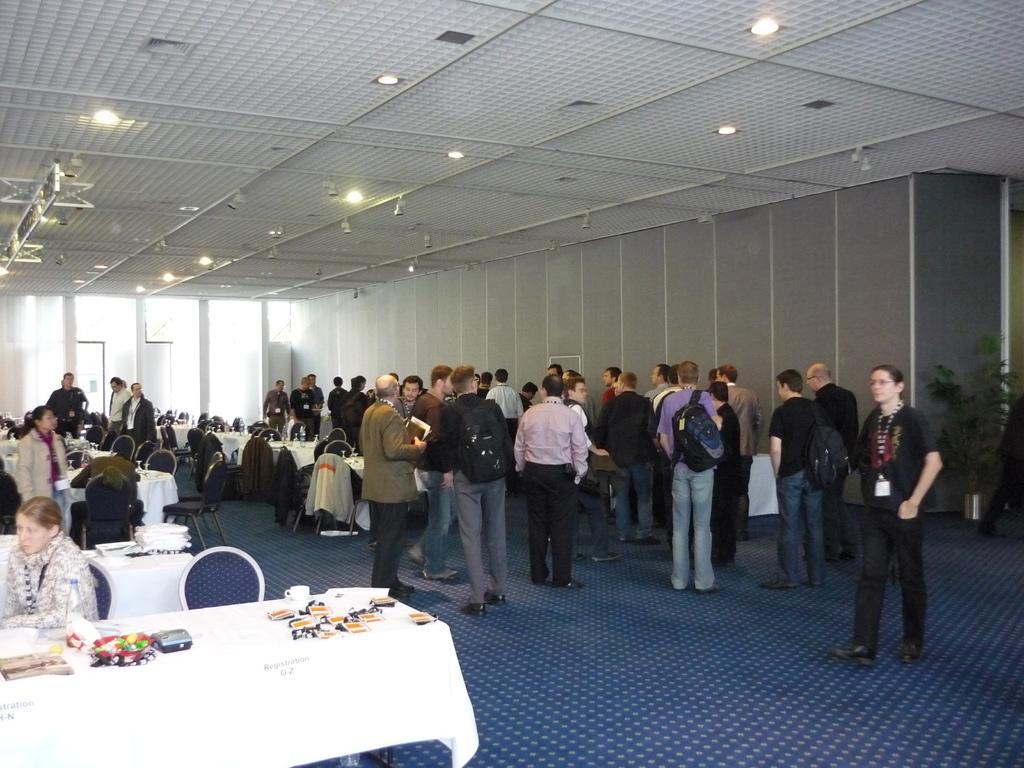Please provide a concise description of this image. In this image in the front there is a table and on the table there are objects and in the background there are persons standing and sitting and there are empty chairs, there are tables and there are lights on the top. On the right side there is a plant and in the background there is a door. 